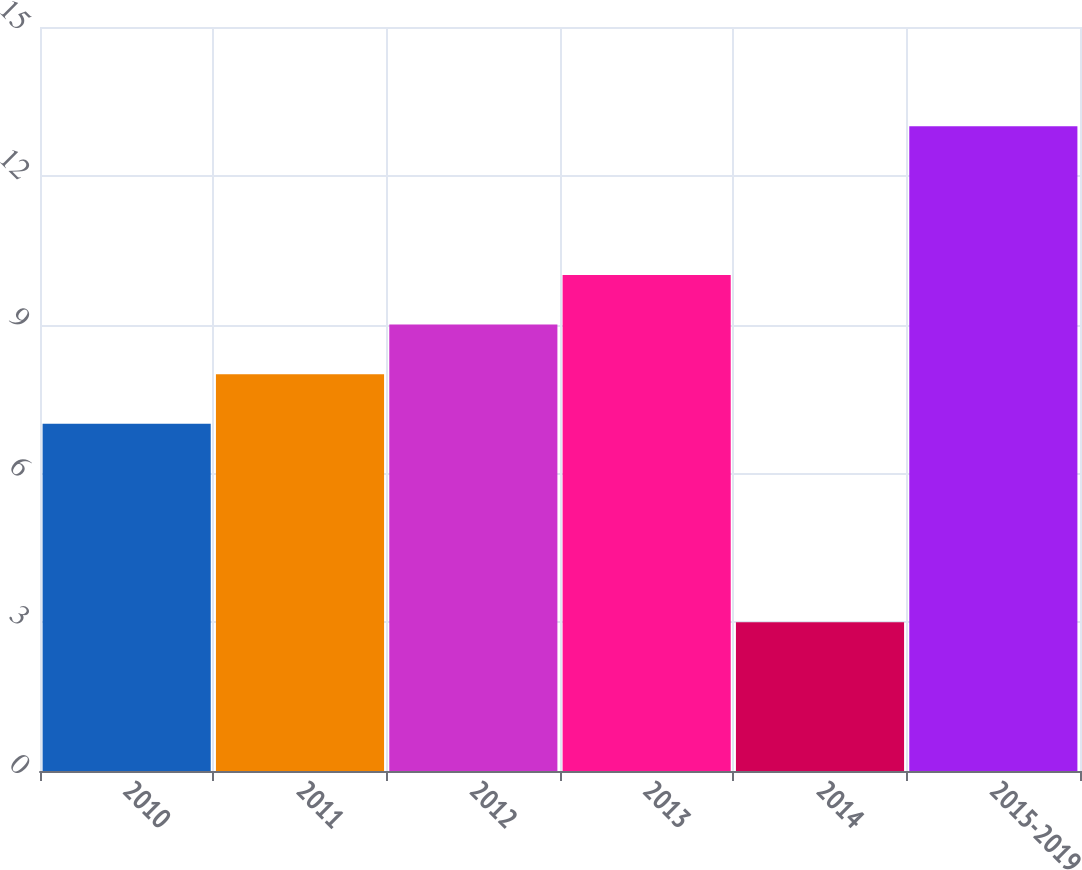Convert chart. <chart><loc_0><loc_0><loc_500><loc_500><bar_chart><fcel>2010<fcel>2011<fcel>2012<fcel>2013<fcel>2014<fcel>2015-2019<nl><fcel>7<fcel>8<fcel>9<fcel>10<fcel>3<fcel>13<nl></chart> 